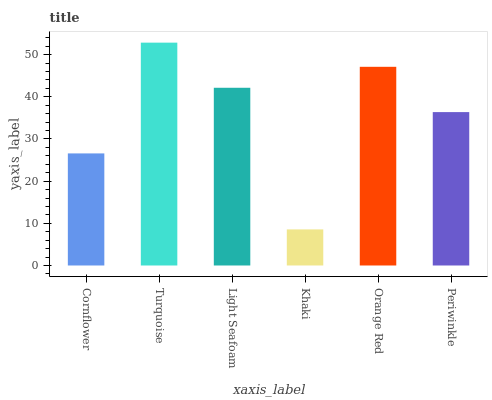Is Khaki the minimum?
Answer yes or no. Yes. Is Turquoise the maximum?
Answer yes or no. Yes. Is Light Seafoam the minimum?
Answer yes or no. No. Is Light Seafoam the maximum?
Answer yes or no. No. Is Turquoise greater than Light Seafoam?
Answer yes or no. Yes. Is Light Seafoam less than Turquoise?
Answer yes or no. Yes. Is Light Seafoam greater than Turquoise?
Answer yes or no. No. Is Turquoise less than Light Seafoam?
Answer yes or no. No. Is Light Seafoam the high median?
Answer yes or no. Yes. Is Periwinkle the low median?
Answer yes or no. Yes. Is Orange Red the high median?
Answer yes or no. No. Is Khaki the low median?
Answer yes or no. No. 